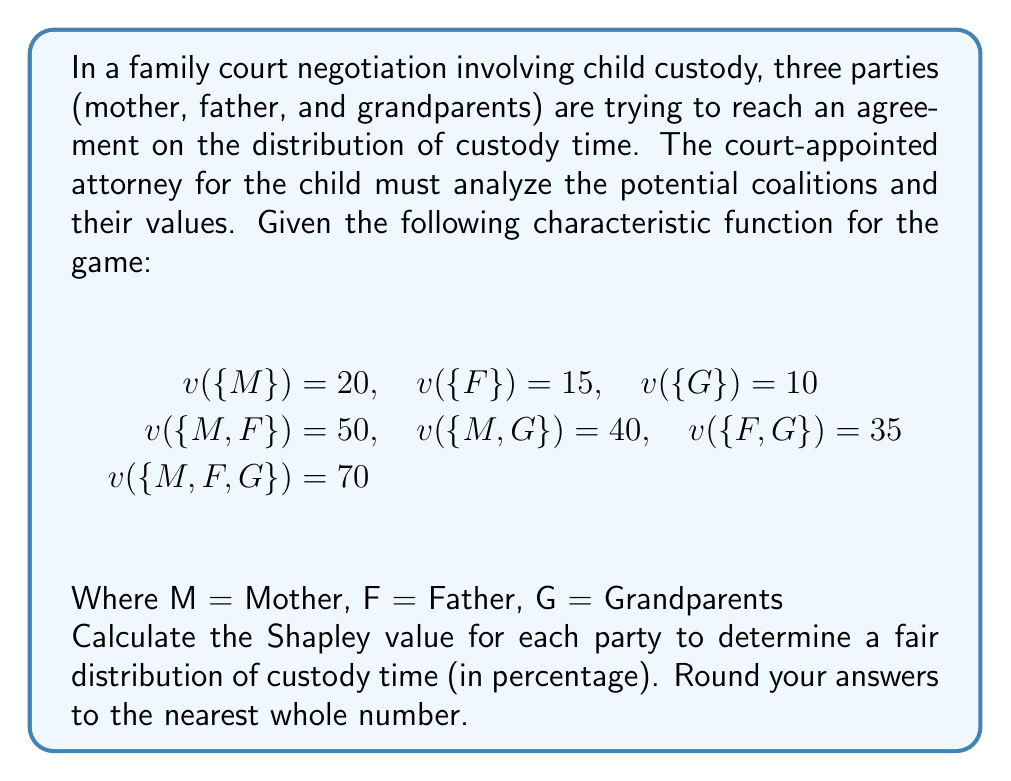Provide a solution to this math problem. To calculate the Shapley value for each party, we need to follow these steps:

1. List all possible orderings of the players:
   MFG, MGF, FMG, FGM, GMF, GFM

2. Calculate the marginal contribution of each player in each ordering:

   M: (20, 20, 35, 35, 30, 35)
   F: (30, 15, 15, 25, 15, 25)
   G: (20, 35, 20, 10, 10, 10)

3. Calculate the average of these contributions for each player:

   For M: $\phi_M = \frac{20 + 20 + 35 + 35 + 30 + 35}{6} = \frac{175}{6} \approx 29.17$

   For F: $\phi_F = \frac{30 + 15 + 15 + 25 + 15 + 25}{6} = \frac{125}{6} \approx 20.83$

   For G: $\phi_G = \frac{20 + 35 + 20 + 10 + 10 + 10}{6} = \frac{105}{6} = 17.5$

4. Convert these values to percentages:

   Total: $29.17 + 20.83 + 17.5 = 67.5$

   M: $\frac{29.17}{67.5} \times 100\% \approx 43.21\%$
   F: $\frac{20.83}{67.5} \times 100\% \approx 30.86\%$
   G: $\frac{17.5}{67.5} \times 100\% \approx 25.93\%$

5. Round to the nearest whole number:

   M: 43%
   F: 31%
   G: 26%
Answer: Mother: 43%, Father: 31%, Grandparents: 26% 